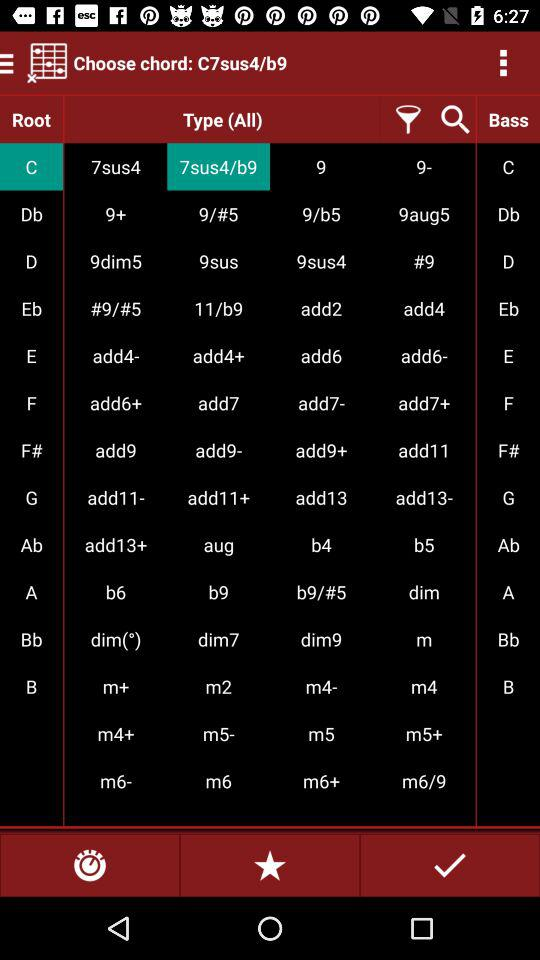What is the chosen chord? The chosen chord is "C7sus4/b9". 